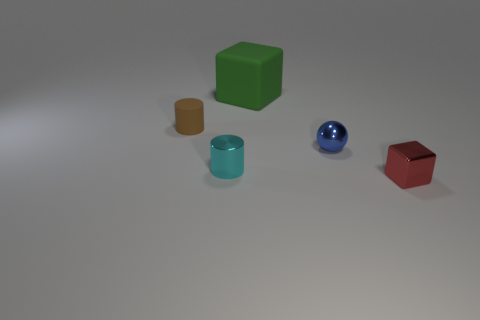How many large objects are brown matte things or green rubber blocks?
Give a very brief answer. 1. What color is the thing that is in front of the cylinder that is in front of the rubber thing on the left side of the tiny cyan metallic cylinder?
Provide a succinct answer. Red. What number of other things are there of the same color as the tiny block?
Offer a terse response. 0. How many metal objects are either big cyan cubes or large green things?
Give a very brief answer. 0. There is a metallic thing on the left side of the big cube; is it the same color as the object that is left of the cyan metallic cylinder?
Offer a very short reply. No. What is the size of the other object that is the same shape as the brown rubber thing?
Keep it short and to the point. Small. Is the number of small red objects in front of the rubber cylinder greater than the number of small yellow cubes?
Make the answer very short. Yes. Is the cube that is to the right of the big green rubber object made of the same material as the tiny cyan object?
Give a very brief answer. Yes. What is the size of the object behind the rubber object to the left of the shiny object that is to the left of the big green thing?
Provide a short and direct response. Large. There is a cyan cylinder that is the same material as the blue sphere; what size is it?
Offer a terse response. Small. 